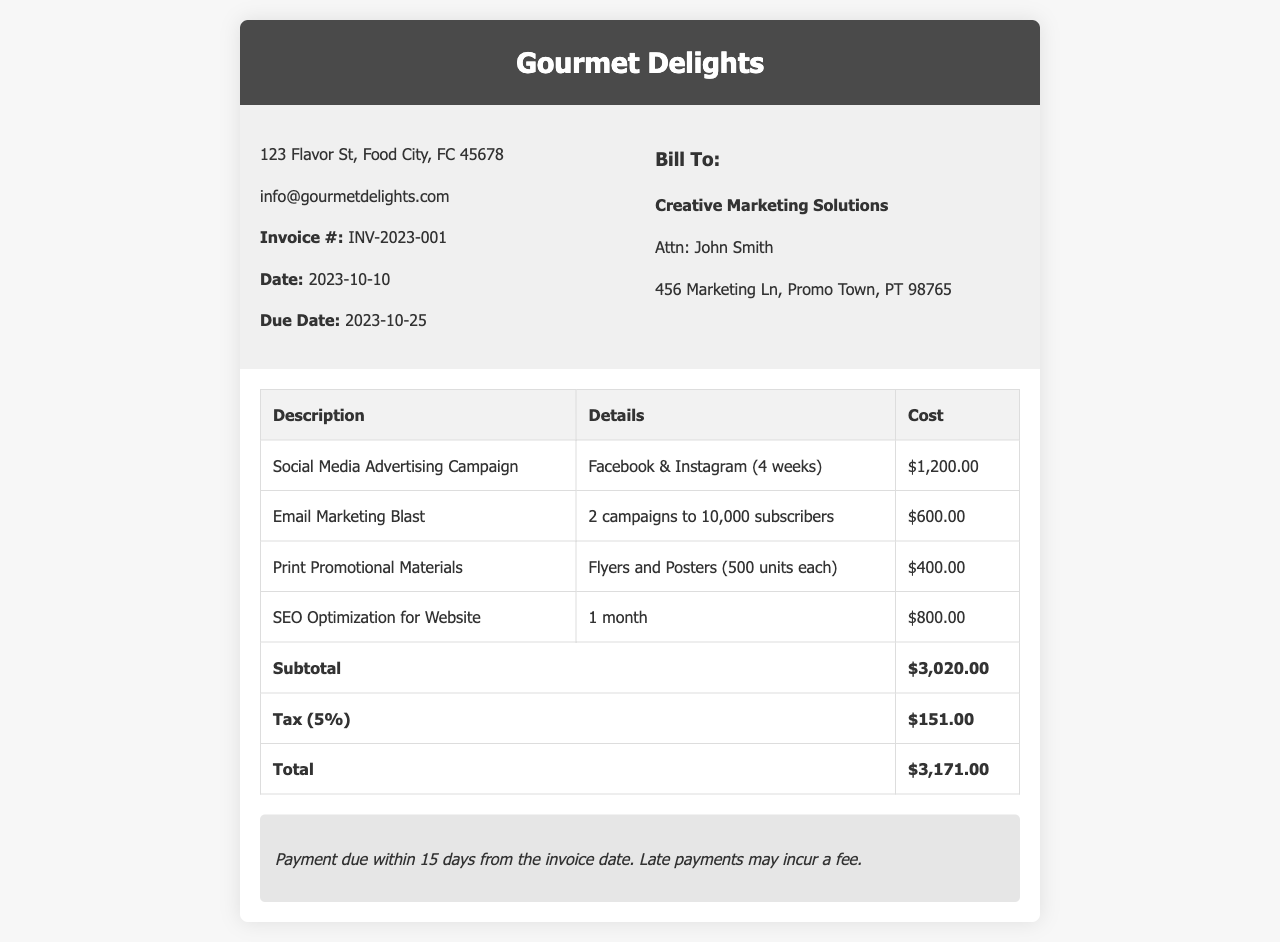What is the invoice number? The invoice number is explicitly stated in the document.
Answer: INV-2023-001 What is the total cost before tax? The total cost before tax is known as the subtotal, which is provided in the breakdown.
Answer: $3,020.00 Who is the client? The document lists the client information in a specific section.
Answer: Creative Marketing Solutions What is the due date of the invoice? The due date is mentioned directly under the invoice details section.
Answer: 2023-10-25 How much is charged for the Social Media Advertising Campaign? The cost for the Social Media Advertising Campaign is clearly indicated.
Answer: $1,200.00 What is the tax rate applied in this invoice? The tax rate can be inferred from the tax section of the document.
Answer: 5% What services were included in the invoice? The document provides a detailed breakdown of services rendered in the table.
Answer: Social Media Advertising, Email Marketing, Print Materials, SEO How many email marketing campaigns were executed? The number of email marketing campaigns is stated in the details of that service.
Answer: 2 What is the total amount due? The document specifies the total amount due after including tax.
Answer: $3,171.00 